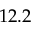Convert formula to latex. <formula><loc_0><loc_0><loc_500><loc_500>1 2 . 2</formula> 